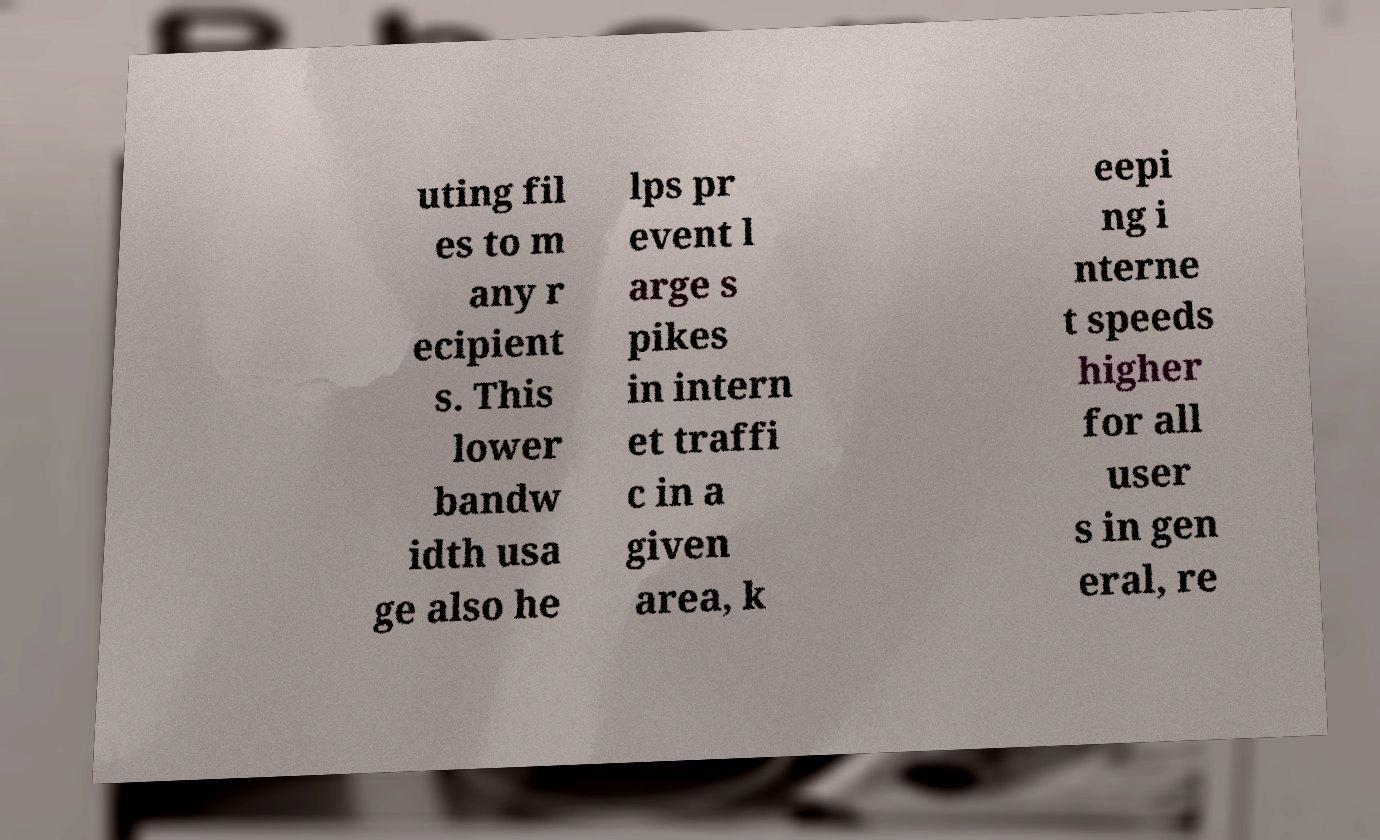Can you read and provide the text displayed in the image?This photo seems to have some interesting text. Can you extract and type it out for me? uting fil es to m any r ecipient s. This lower bandw idth usa ge also he lps pr event l arge s pikes in intern et traffi c in a given area, k eepi ng i nterne t speeds higher for all user s in gen eral, re 